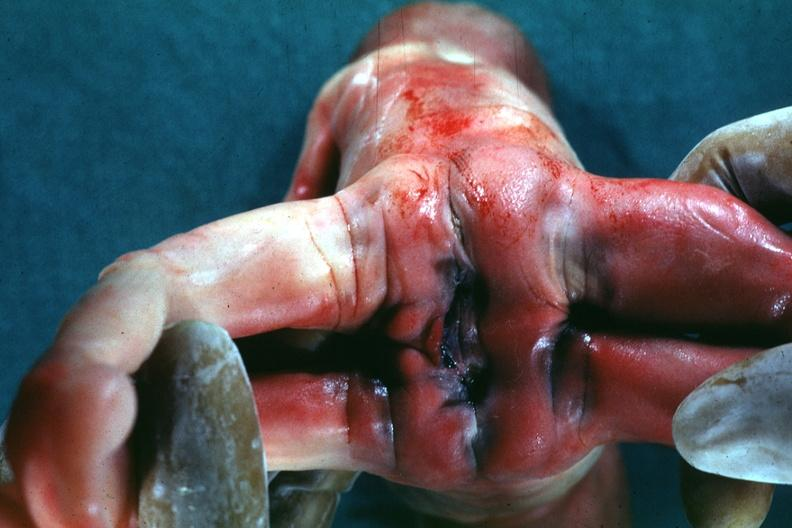what is present?
Answer the question using a single word or phrase. Siamese twins 